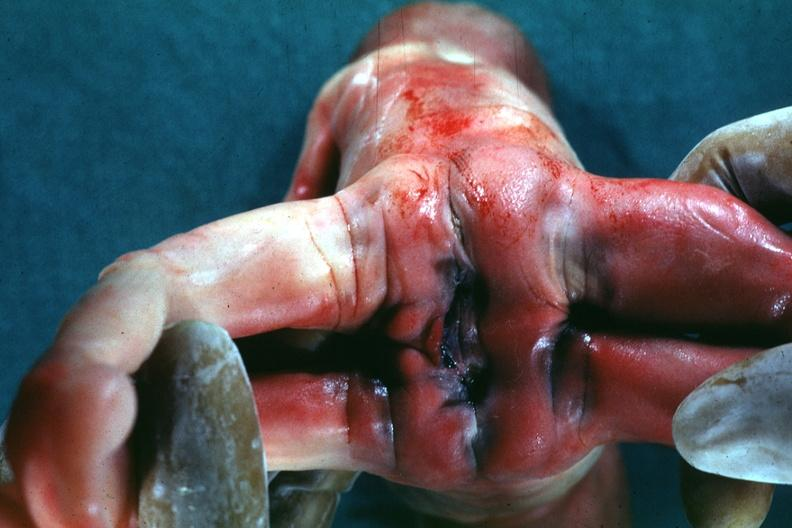what is present?
Answer the question using a single word or phrase. Siamese twins 